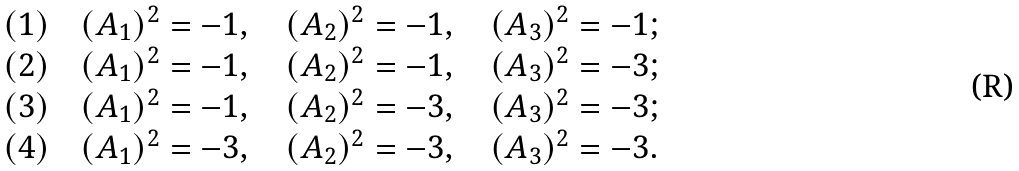<formula> <loc_0><loc_0><loc_500><loc_500>\begin{array} { l l } ( 1 ) \quad ( A _ { 1 } ) ^ { 2 } = - 1 , \quad ( A _ { 2 } ) ^ { 2 } = - 1 , \quad ( A _ { 3 } ) ^ { 2 } = - 1 ; \\ ( 2 ) \quad ( A _ { 1 } ) ^ { 2 } = - 1 , \quad ( A _ { 2 } ) ^ { 2 } = - 1 , \quad ( A _ { 3 } ) ^ { 2 } = - 3 ; \\ ( 3 ) \quad ( A _ { 1 } ) ^ { 2 } = - 1 , \quad ( A _ { 2 } ) ^ { 2 } = - 3 , \quad ( A _ { 3 } ) ^ { 2 } = - 3 ; \\ ( 4 ) \quad ( A _ { 1 } ) ^ { 2 } = - 3 , \quad ( A _ { 2 } ) ^ { 2 } = - 3 , \quad ( A _ { 3 } ) ^ { 2 } = - 3 . \\ \end{array}</formula> 